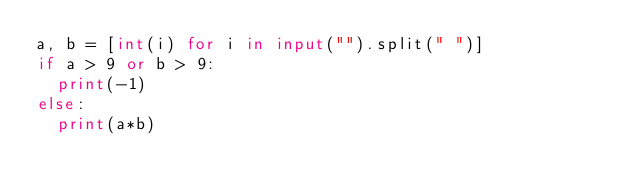Convert code to text. <code><loc_0><loc_0><loc_500><loc_500><_Python_>a, b = [int(i) for i in input("").split(" ")]
if a > 9 or b > 9:
  print(-1)
else:
  print(a*b)</code> 